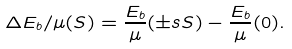<formula> <loc_0><loc_0><loc_500><loc_500>\Delta E _ { b } / \mu ( S ) = \frac { E _ { b } } { \mu } ( \pm s { S } ) - \frac { E _ { b } } { \mu } ( 0 ) .</formula> 